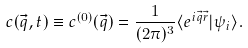<formula> <loc_0><loc_0><loc_500><loc_500>c ( \vec { q } , t ) \equiv c ^ { ( 0 ) } ( \vec { q } ) = \frac { 1 } { ( 2 \pi ) ^ { 3 } } \langle e ^ { i \vec { q } \vec { r } } | \psi _ { i } \rangle .</formula> 